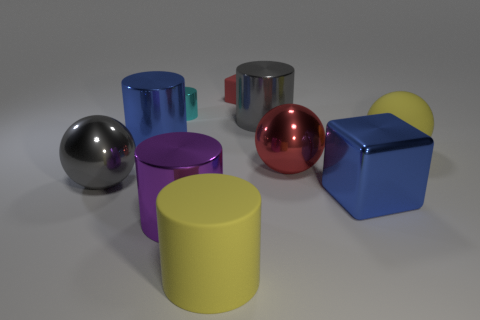Subtract all rubber cylinders. How many cylinders are left? 4 Subtract all gray cylinders. How many cylinders are left? 4 Subtract all red cylinders. Subtract all yellow cubes. How many cylinders are left? 5 Subtract all balls. How many objects are left? 7 Add 2 gray shiny spheres. How many gray shiny spheres exist? 3 Subtract 0 purple cubes. How many objects are left? 10 Subtract all cyan rubber cubes. Subtract all tiny red matte cubes. How many objects are left? 9 Add 4 gray cylinders. How many gray cylinders are left? 5 